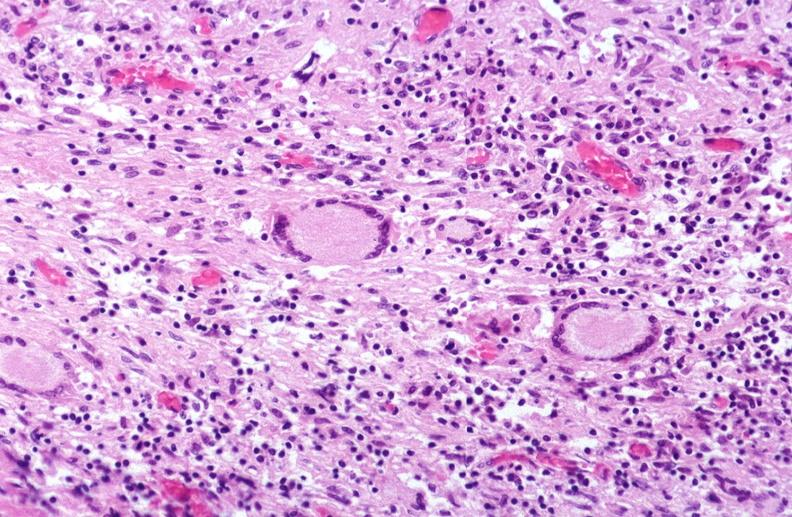where is this?
Answer the question using a single word or phrase. Lung 